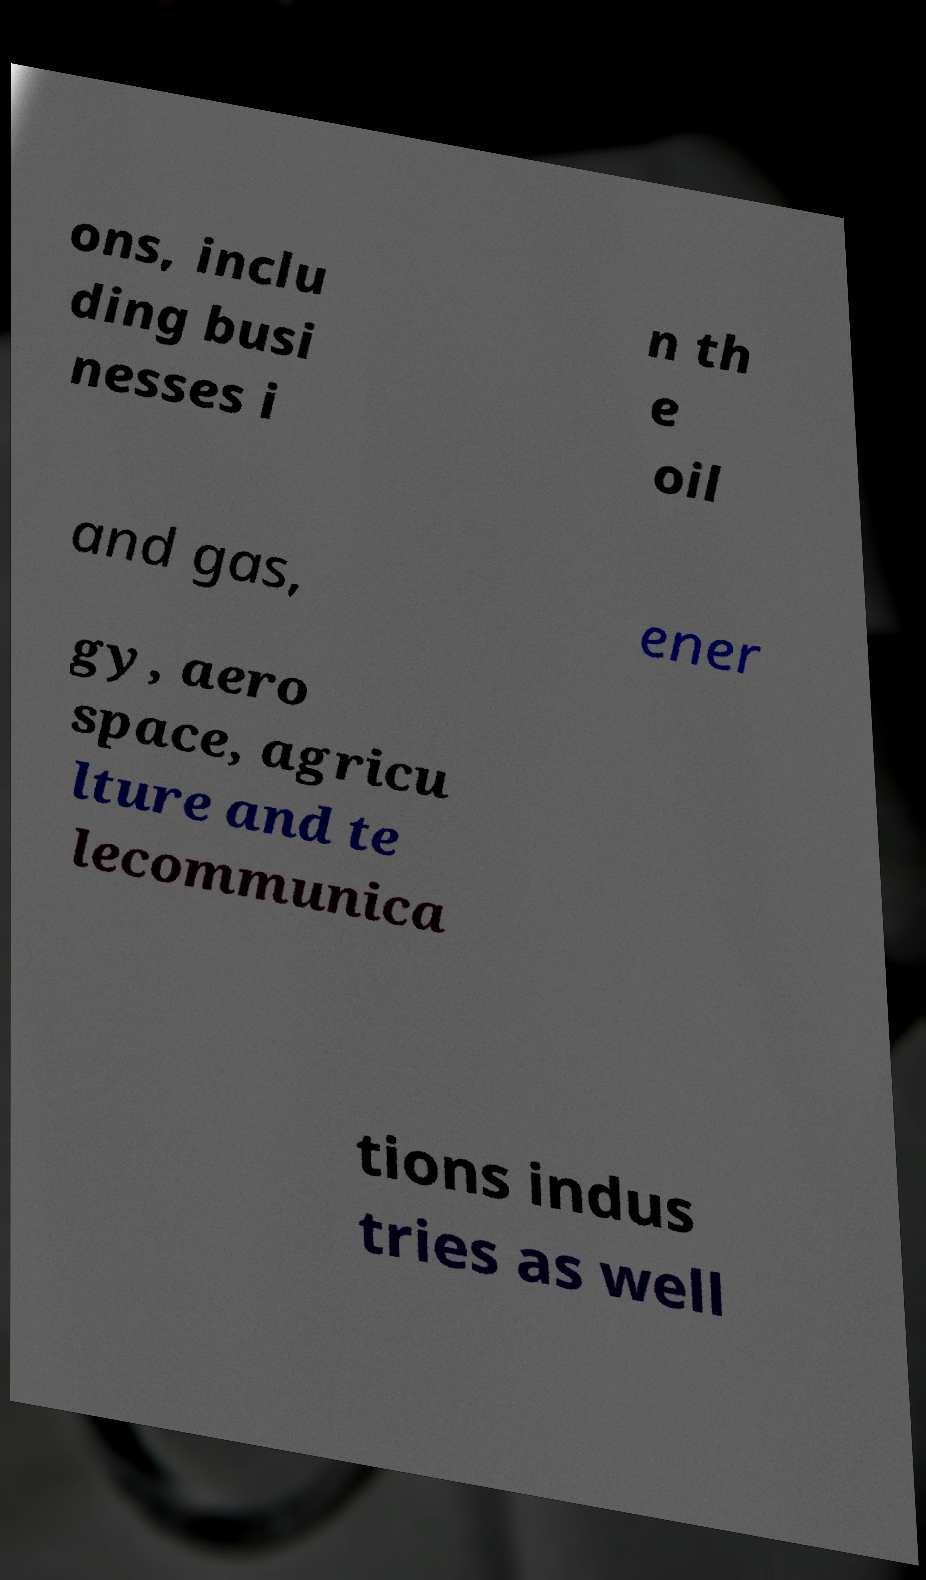Can you accurately transcribe the text from the provided image for me? ons, inclu ding busi nesses i n th e oil and gas, ener gy, aero space, agricu lture and te lecommunica tions indus tries as well 